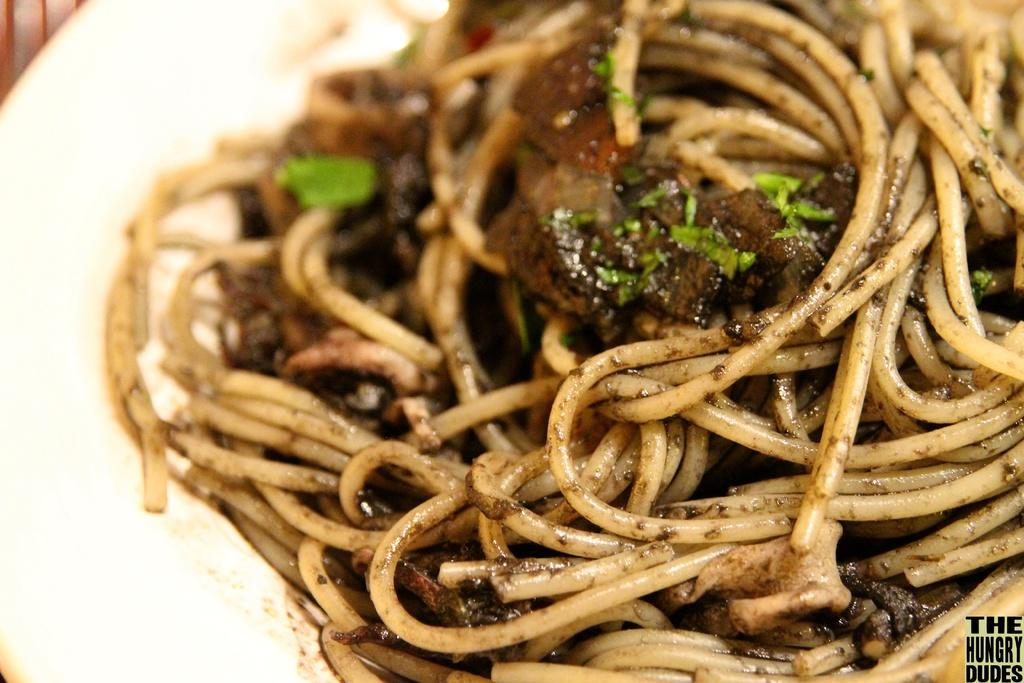What is the color of the plate or bowl in the image? The plate or bowl in the image is white. What is inside the plate or bowl? The plate or bowl contains noodles. What song is being played in the background of the image? There is no information about a song being played in the image. Can you see a hill in the image? There is no hill visible in the image. 